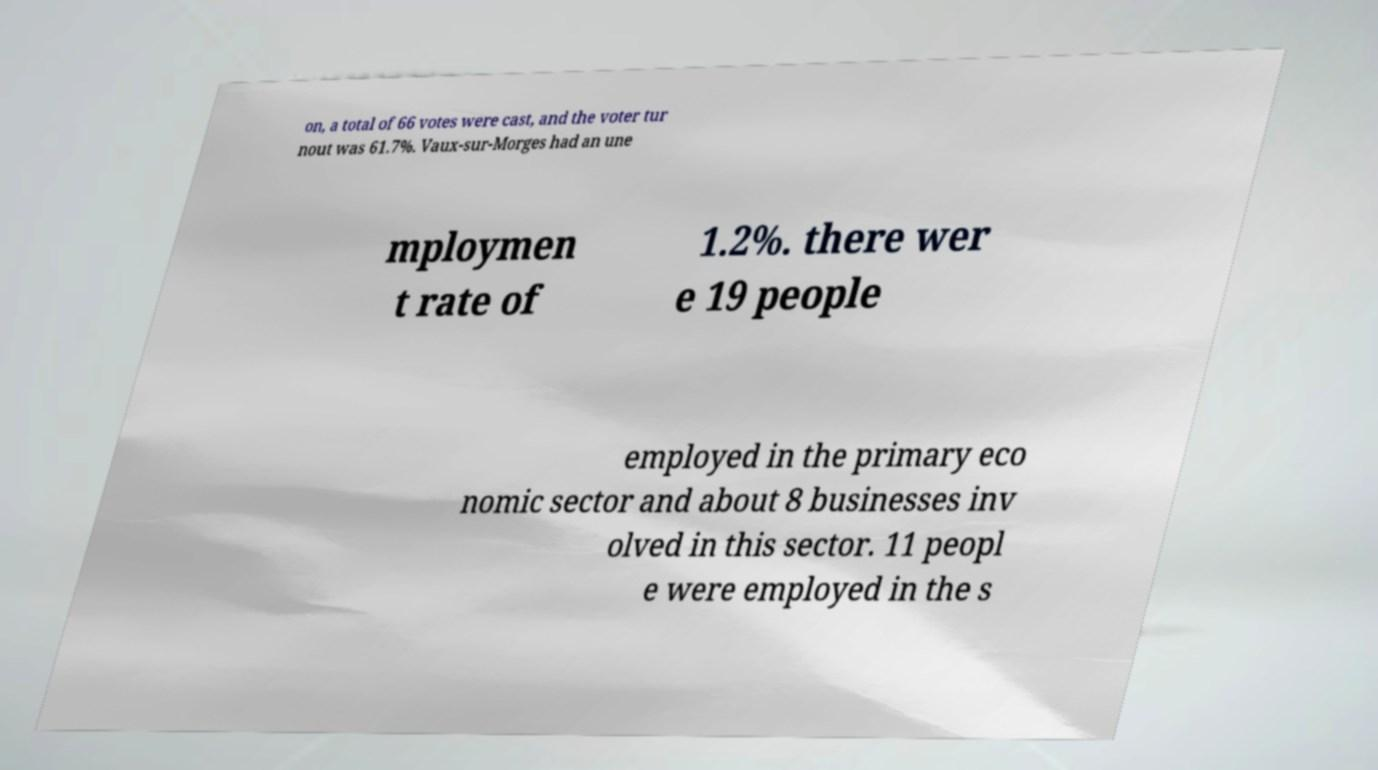There's text embedded in this image that I need extracted. Can you transcribe it verbatim? on, a total of 66 votes were cast, and the voter tur nout was 61.7%. Vaux-sur-Morges had an une mploymen t rate of 1.2%. there wer e 19 people employed in the primary eco nomic sector and about 8 businesses inv olved in this sector. 11 peopl e were employed in the s 